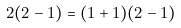Convert formula to latex. <formula><loc_0><loc_0><loc_500><loc_500>2 ( 2 - 1 ) = ( 1 + 1 ) ( 2 - 1 )</formula> 